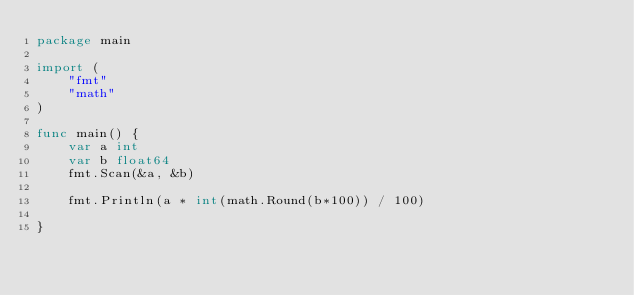<code> <loc_0><loc_0><loc_500><loc_500><_Go_>package main

import (
	"fmt"
	"math"
)

func main() {
	var a int
	var b float64
	fmt.Scan(&a, &b)

	fmt.Println(a * int(math.Round(b*100)) / 100)

}
</code> 